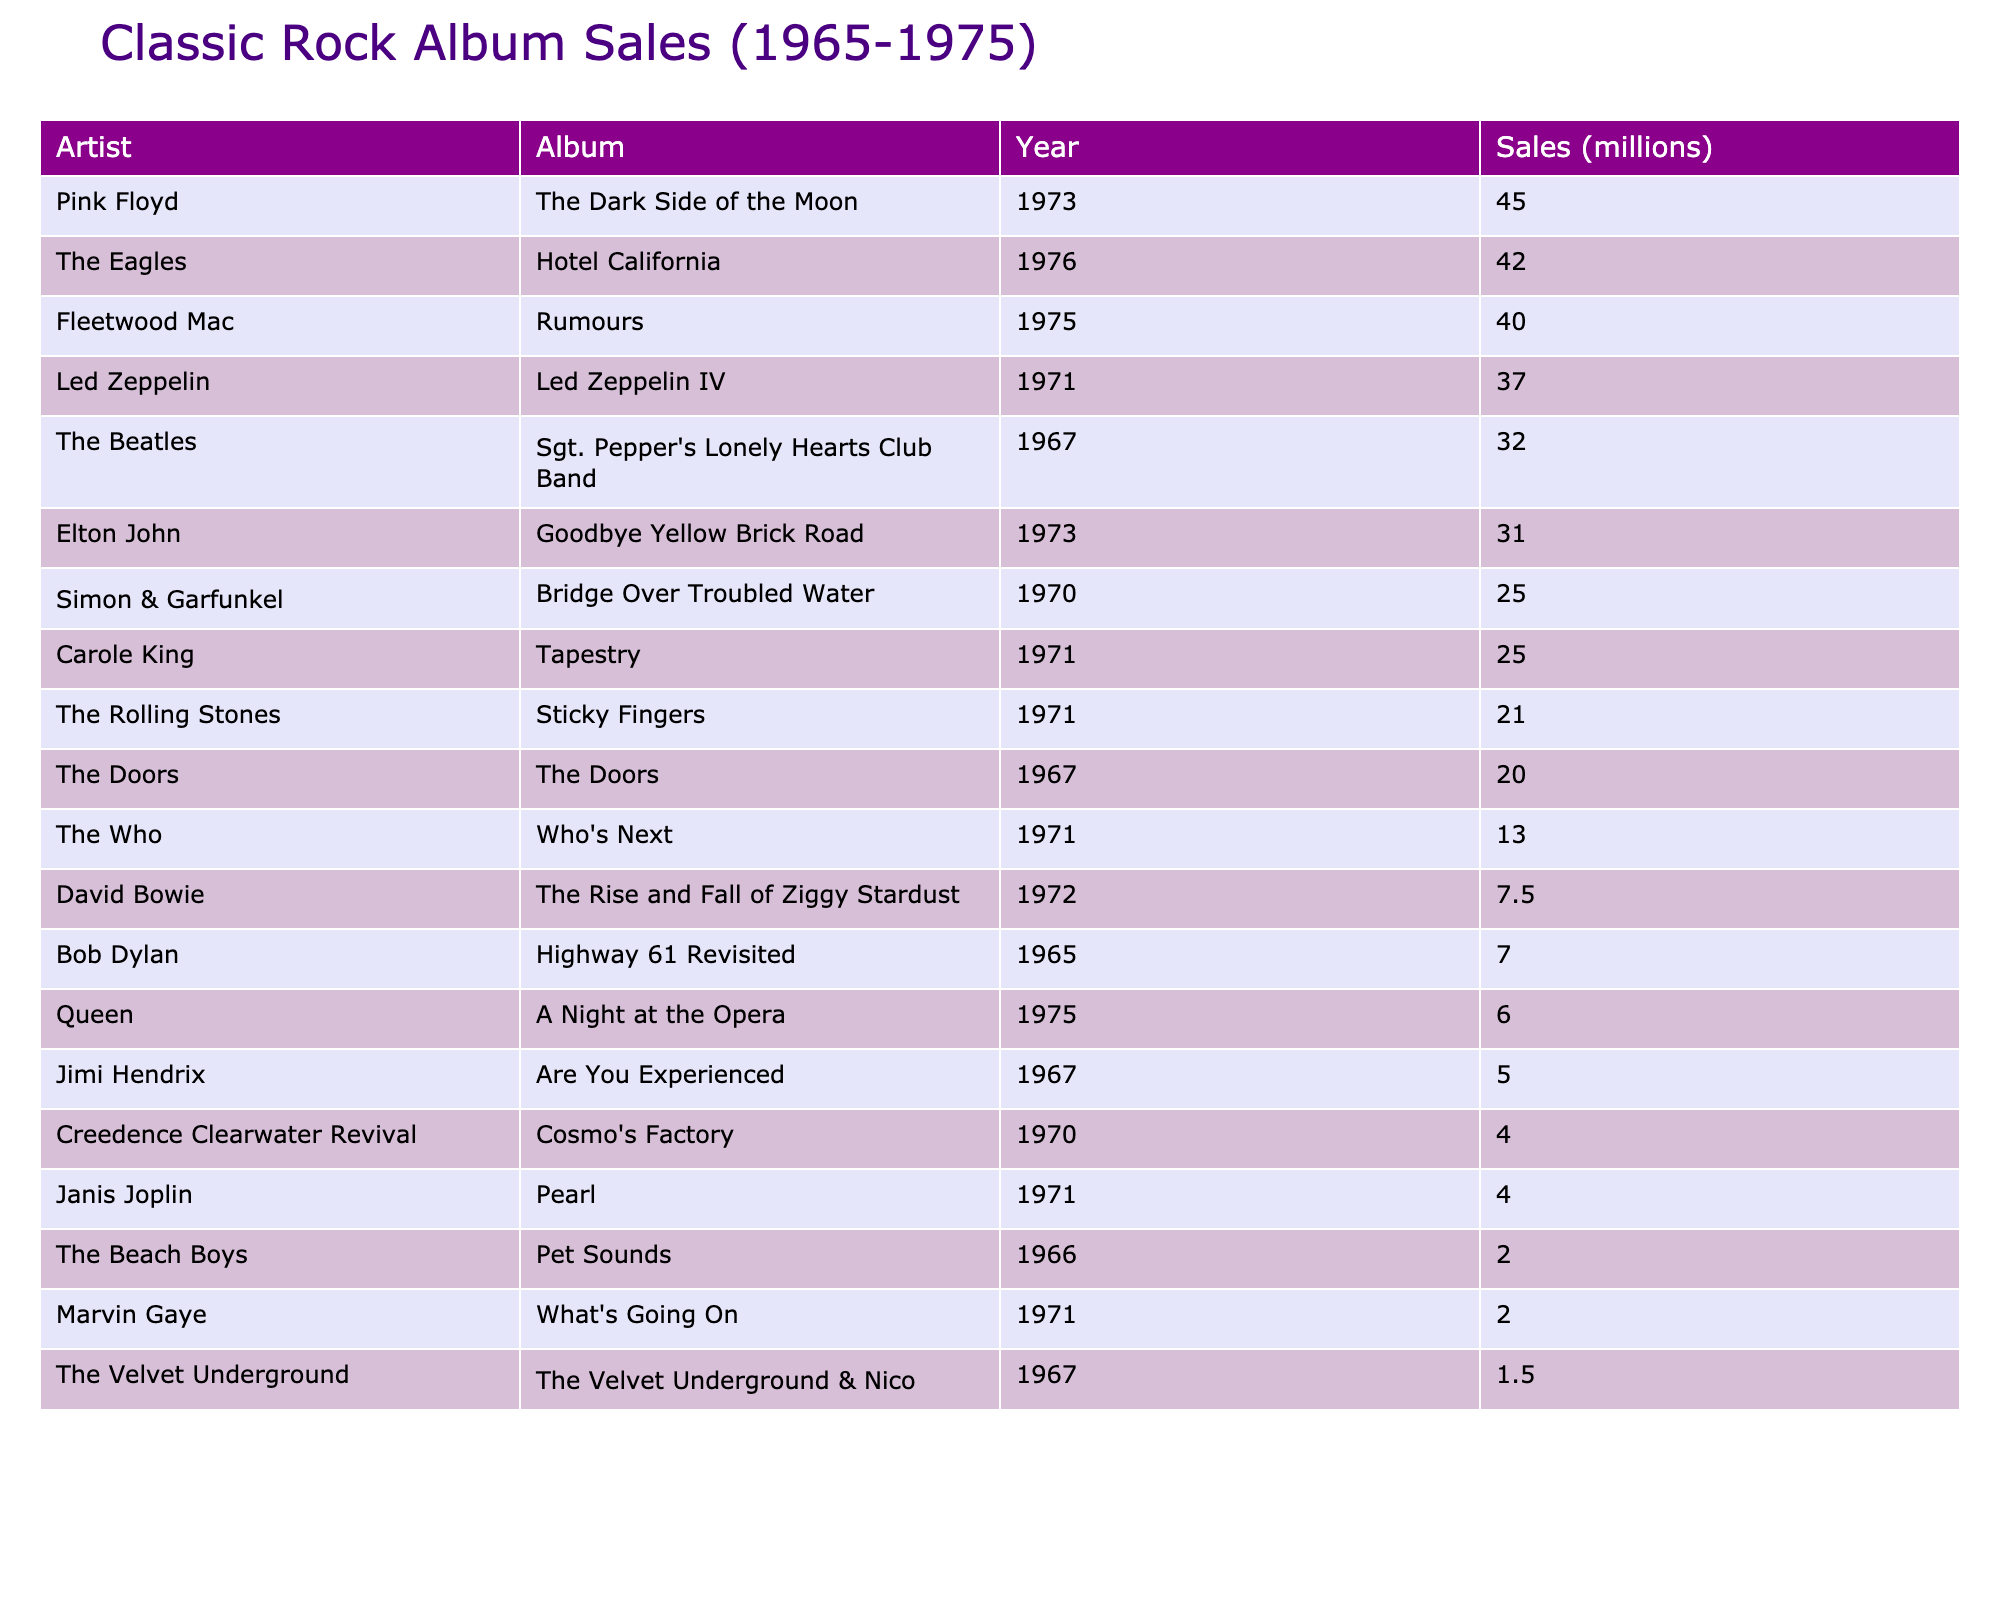What album had the highest sales? The table shows the sales for each album, and "The Dark Side of the Moon" is listed with sales of 45 million, which is the highest value in the sales column.
Answer: The Dark Side of the Moon Which artist released the album with the lowest sales? The lowest sales figure in the table is for "The Velvet Underground & Nico," which sold 1.5 million. This indicates that The Velvet Underground is the artist associated with the lowest sales.
Answer: The Velvet Underground What is the total sales of albums released by Led Zeppelin and The Rolling Stones? To find the total, we add Led Zeppelin's sales of 37 million and The Rolling Stones' sales of 21 million. The total is 37 + 21 = 58 million.
Answer: 58 million How many albums sold more than 30 million copies? By referencing the sales figures, the albums that sold more than 30 million are "Sgt. Pepper's Lonely Hearts Club Band" (32), "Led Zeppelin IV" (37), "The Dark Side of the Moon" (45), and "Goodbye Yellow Brick Road" (31). There are 4 albums in total.
Answer: 4 What is the difference in sales between Fleetwood Mac’s "Rumours" and Elton John's "Goodbye Yellow Brick Road"? Fleetwood Mac’s "Rumours" sold 40 million, while Elton John's "Goodbye Yellow Brick Road" sold 31 million. The difference is calculated as 40 - 31 = 9 million.
Answer: 9 million Was Bob Dylan’s "Highway 61 Revisited" one of the top 5 best-selling albums? Checking the sales figures, "Highway 61 Revisited" sold 7 million, which does not place it in the top 5 since the fifth highest album, "Bridge Over Troubled Water," had 25 million. Therefore, it is not.
Answer: No What is the average sales figure of the albums released in 1971? The albums released in 1971 are "Led Zeppelin IV" (37), "The Rolling Stones' Sticky Fingers" (21), "Who's Next" (13), "Janis Joplin's Pearl" (4), and "What's Going On" (2). We sum these sales (37 + 21 + 13 + 4 + 2) = 77 million, and divide by the number of albums (5), resulting in an average of 77 / 5 = 15.4 million.
Answer: 15.4 million Which artist has two albums on the list? Upon reviewing the table, it is noted that Elton John is listed with one album, and Fleetwood Mac is similarly listed with one. However, The Who is listed once and does not have two albums. Therefore, no artist has two albums listed.
Answer: None Which year had the highest total sales from all albums released? To ascertain this, we need to sum the sales for albums released in each year. For 1971, we have 37 + 21 + 13 + 4 + 2 = 77 million. For 1973, the total is 45 + 31 = 76 million, 1975 has 40 + 6 = 46 million, 1970 has 25 + 4 = 29 million, and 1967 has 32 + 20 + 5 + 1.5 = 58.5 million. The greatest total comes from 1971 with 77 million.
Answer: 1971 What percentage of the total albums sold does "Sticky Fingers" represent? "Sticky Fingers" sold 21 million. The total sales in the table can be summed as 32 + 37 + 45 + 21 + 13 + 5 + 40 + 7.5 + 20 + 4 + 6 + 31 + 7 + 2 + 4 + 1.5 + 25 + 2 + 25 = 333 million. The percentage is calculated as (21 / 333) * 100 = approximately 6.3%.
Answer: 6.3% 